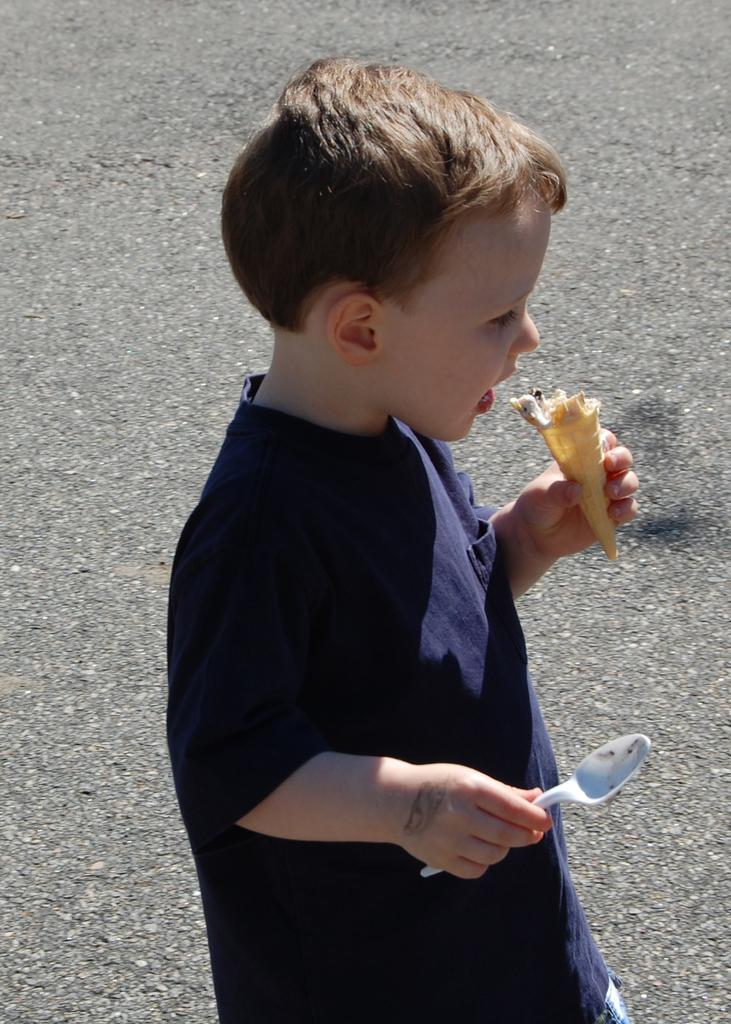Who is the main subject in the image? There is a boy in the image. What is the boy doing in the image? The boy is walking on a road. What is the boy holding in his hands? The boy is holding a spoon and a cone. What type of guitar is the boy playing in the image? There is no guitar present in the image; the boy is holding a spoon and a cone. How many clams can be seen in the image? There are no clams present in the image. 